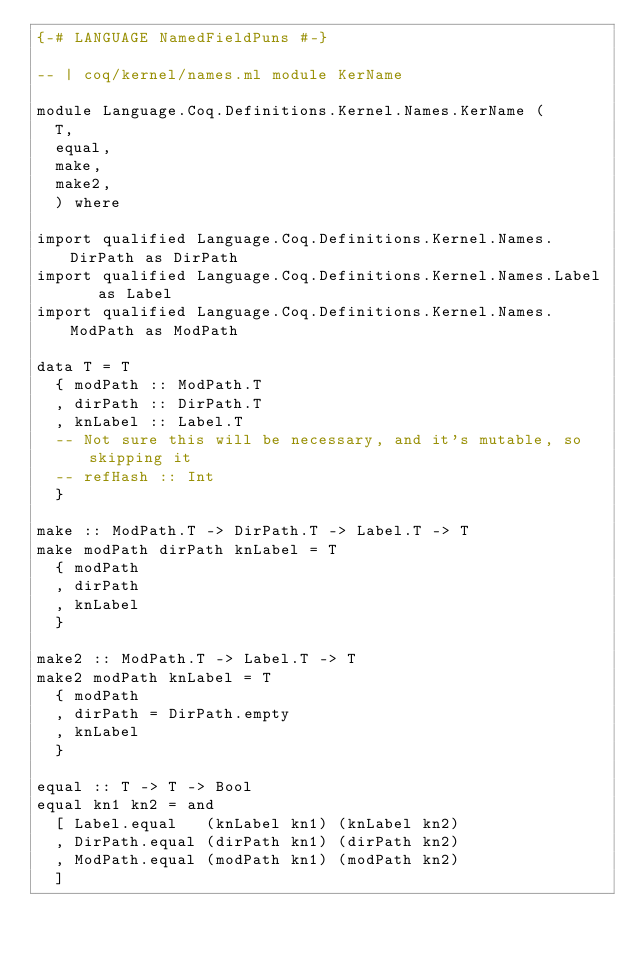Convert code to text. <code><loc_0><loc_0><loc_500><loc_500><_Haskell_>{-# LANGUAGE NamedFieldPuns #-}

-- | coq/kernel/names.ml module KerName

module Language.Coq.Definitions.Kernel.Names.KerName (
  T,
  equal,
  make,
  make2,
  ) where

import qualified Language.Coq.Definitions.Kernel.Names.DirPath as DirPath
import qualified Language.Coq.Definitions.Kernel.Names.Label   as Label
import qualified Language.Coq.Definitions.Kernel.Names.ModPath as ModPath

data T = T
  { modPath :: ModPath.T
  , dirPath :: DirPath.T
  , knLabel :: Label.T
  -- Not sure this will be necessary, and it's mutable, so skipping it
  -- refHash :: Int
  }

make :: ModPath.T -> DirPath.T -> Label.T -> T
make modPath dirPath knLabel = T
  { modPath
  , dirPath
  , knLabel
  }

make2 :: ModPath.T -> Label.T -> T
make2 modPath knLabel = T
  { modPath
  , dirPath = DirPath.empty
  , knLabel
  }

equal :: T -> T -> Bool
equal kn1 kn2 = and
  [ Label.equal   (knLabel kn1) (knLabel kn2)
  , DirPath.equal (dirPath kn1) (dirPath kn2)
  , ModPath.equal (modPath kn1) (modPath kn2)
  ]
</code> 